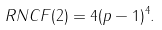Convert formula to latex. <formula><loc_0><loc_0><loc_500><loc_500>R N C F ( 2 ) = 4 ( p - 1 ) ^ { 4 } .</formula> 